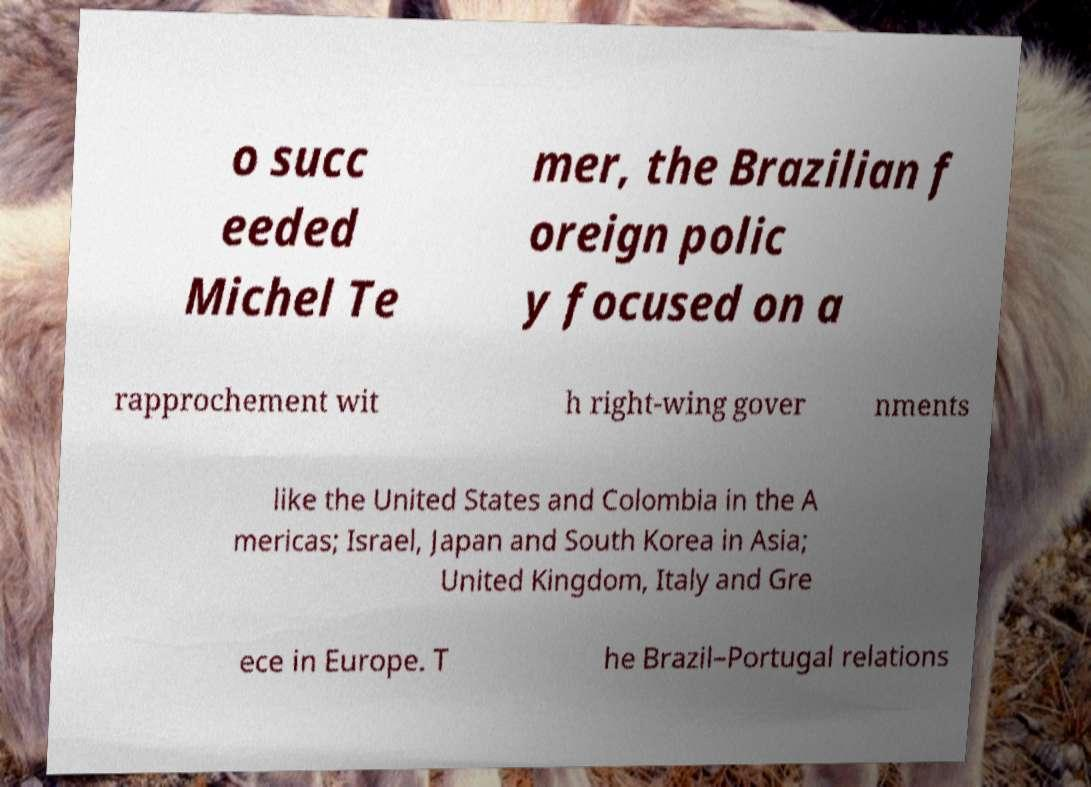What messages or text are displayed in this image? I need them in a readable, typed format. o succ eeded Michel Te mer, the Brazilian f oreign polic y focused on a rapprochement wit h right-wing gover nments like the United States and Colombia in the A mericas; Israel, Japan and South Korea in Asia; United Kingdom, Italy and Gre ece in Europe. T he Brazil–Portugal relations 